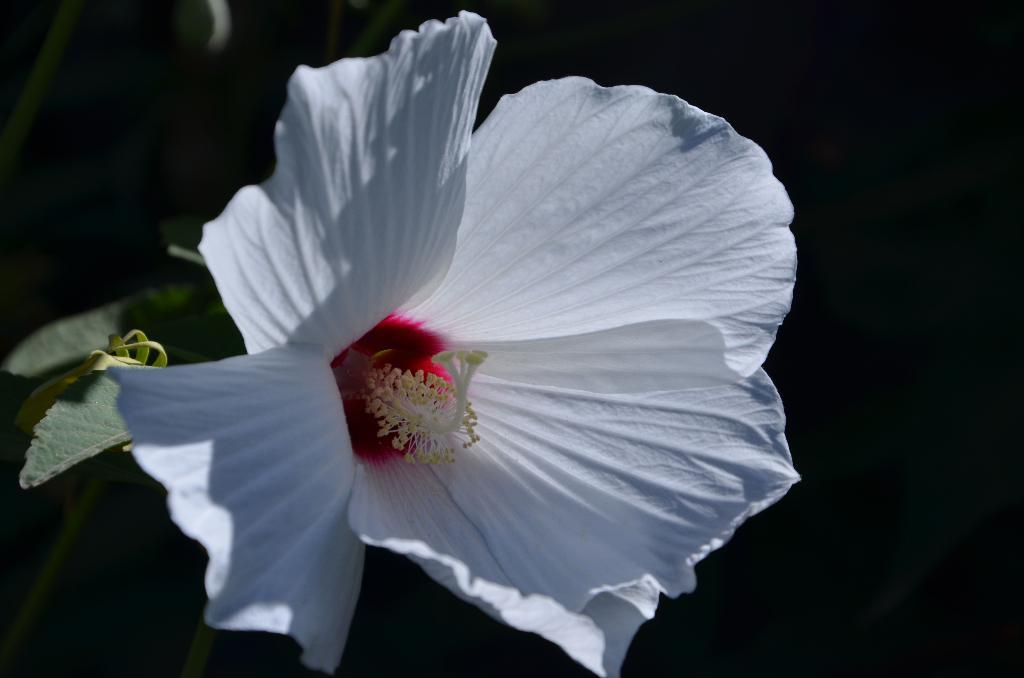What type of plant is featured in the image? There is a white flower in the image. What else can be seen in the image besides the flower? There are leaves in the image. Can you describe the background of the image? The background appears blurry. What type of clover is present in the image? There is no clover present in the image; it features a white flower and leaves. What force is being applied to the flower in the image? There is no force being applied to the flower in the image; it is stationary. 